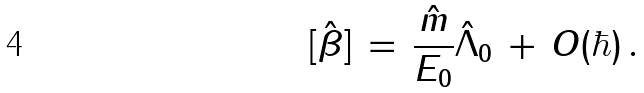<formula> <loc_0><loc_0><loc_500><loc_500>[ \hat { \beta } ] \, = \, \frac { \hat { m } } { E _ { 0 } } \hat { \Lambda } _ { 0 } \, + \, O ( \hbar { ) } \, .</formula> 